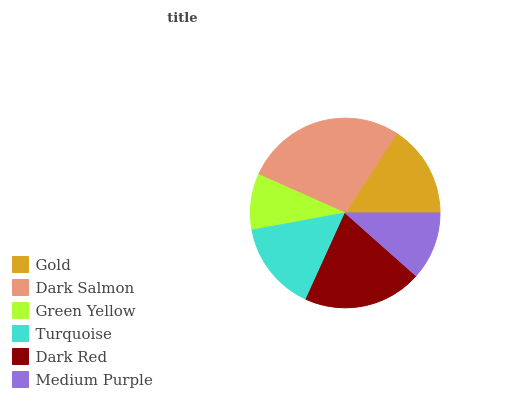Is Green Yellow the minimum?
Answer yes or no. Yes. Is Dark Salmon the maximum?
Answer yes or no. Yes. Is Dark Salmon the minimum?
Answer yes or no. No. Is Green Yellow the maximum?
Answer yes or no. No. Is Dark Salmon greater than Green Yellow?
Answer yes or no. Yes. Is Green Yellow less than Dark Salmon?
Answer yes or no. Yes. Is Green Yellow greater than Dark Salmon?
Answer yes or no. No. Is Dark Salmon less than Green Yellow?
Answer yes or no. No. Is Gold the high median?
Answer yes or no. Yes. Is Turquoise the low median?
Answer yes or no. Yes. Is Medium Purple the high median?
Answer yes or no. No. Is Medium Purple the low median?
Answer yes or no. No. 